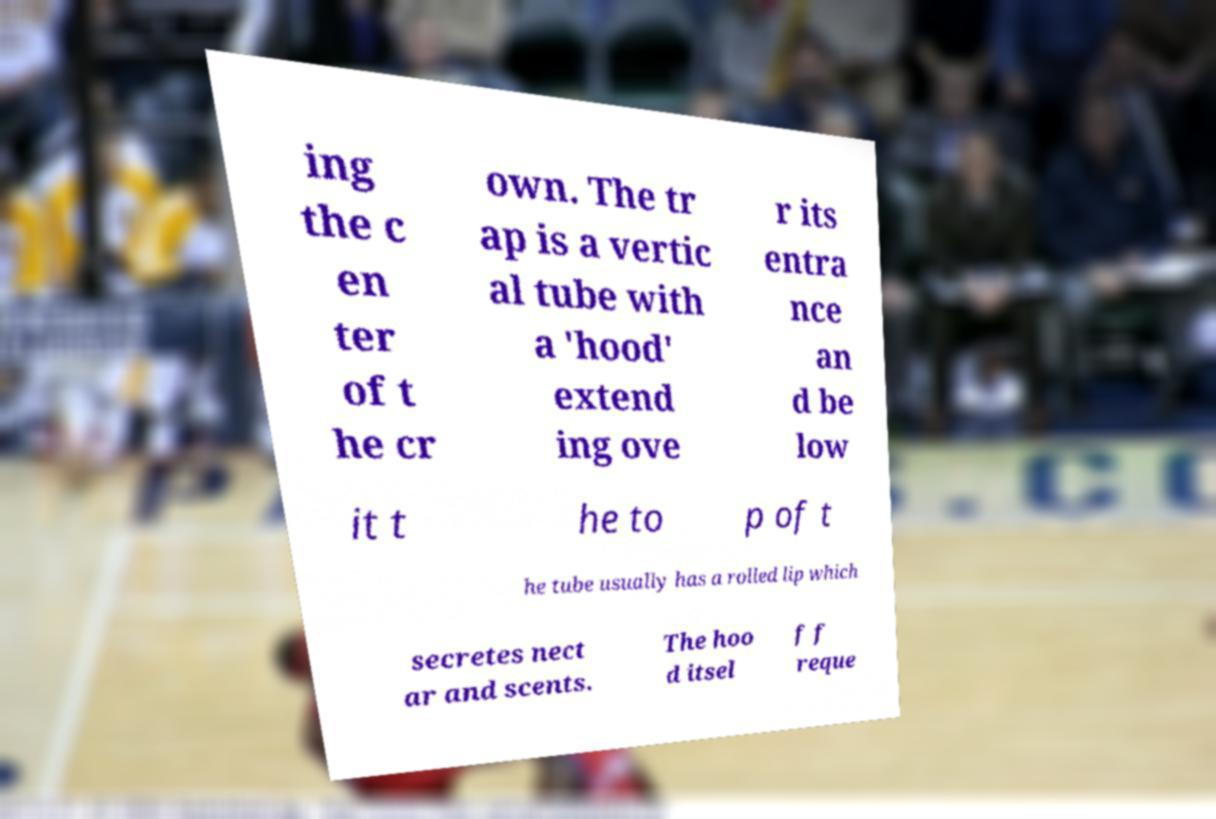What messages or text are displayed in this image? I need them in a readable, typed format. ing the c en ter of t he cr own. The tr ap is a vertic al tube with a 'hood' extend ing ove r its entra nce an d be low it t he to p of t he tube usually has a rolled lip which secretes nect ar and scents. The hoo d itsel f f reque 